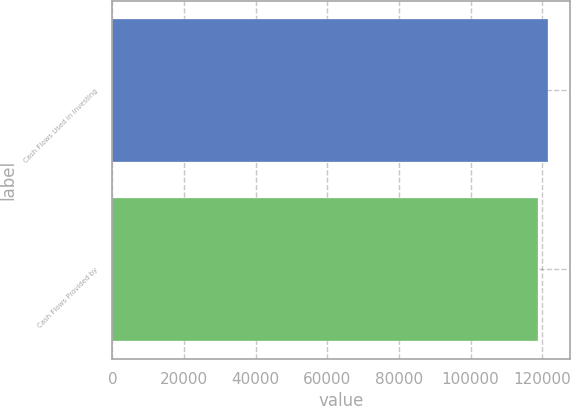Convert chart. <chart><loc_0><loc_0><loc_500><loc_500><bar_chart><fcel>Cash Flows Used in Investing<fcel>Cash Flows Provided by<nl><fcel>121658<fcel>118910<nl></chart> 